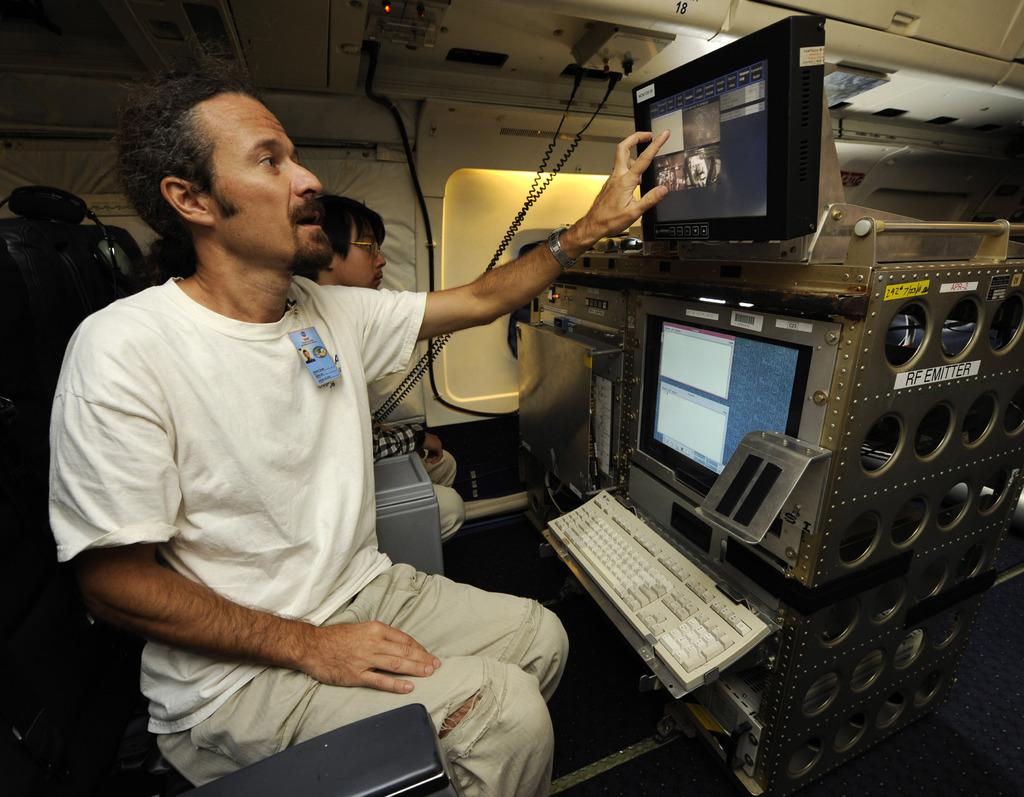Provide a one-sentence caption for the provided image. The RF Emitter looks like a complicated piece of flight equiment, requiring the trained operator, which is touching the top monitor, to understand the software. 